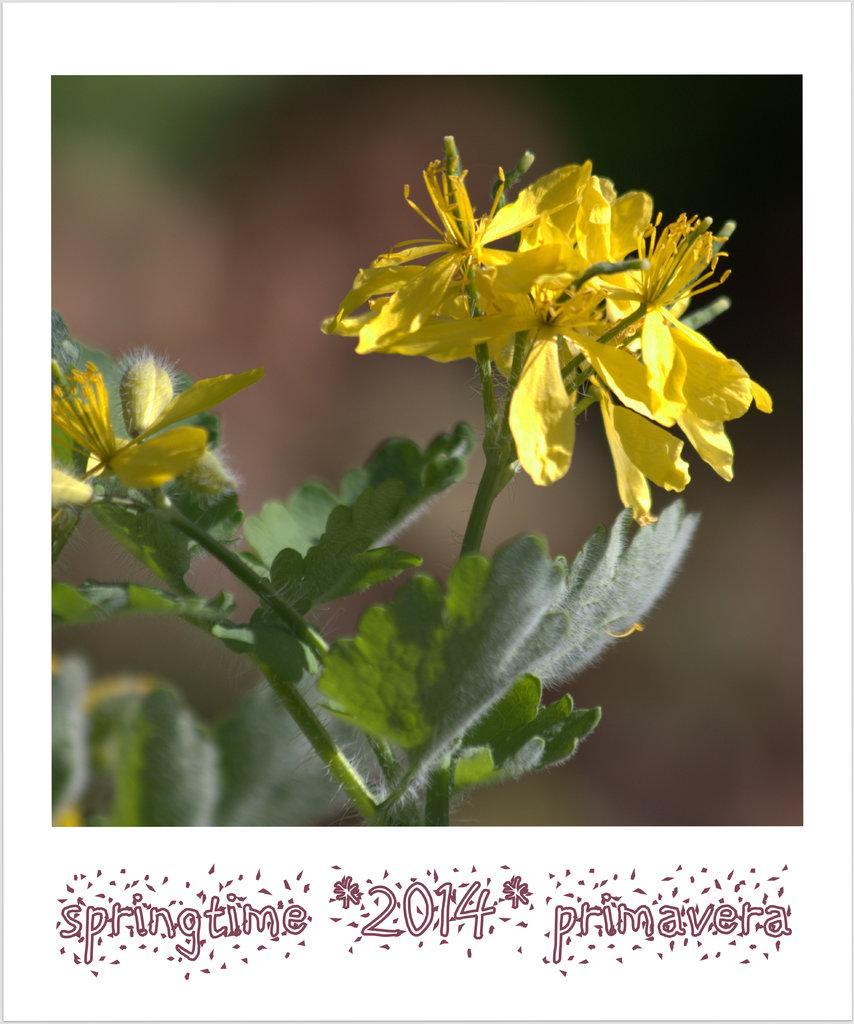In one or two sentences, can you explain what this image depicts? In this image we can see yellow flowers and green leaves. Background it is blur. Bottom of the image there is a watermark. 